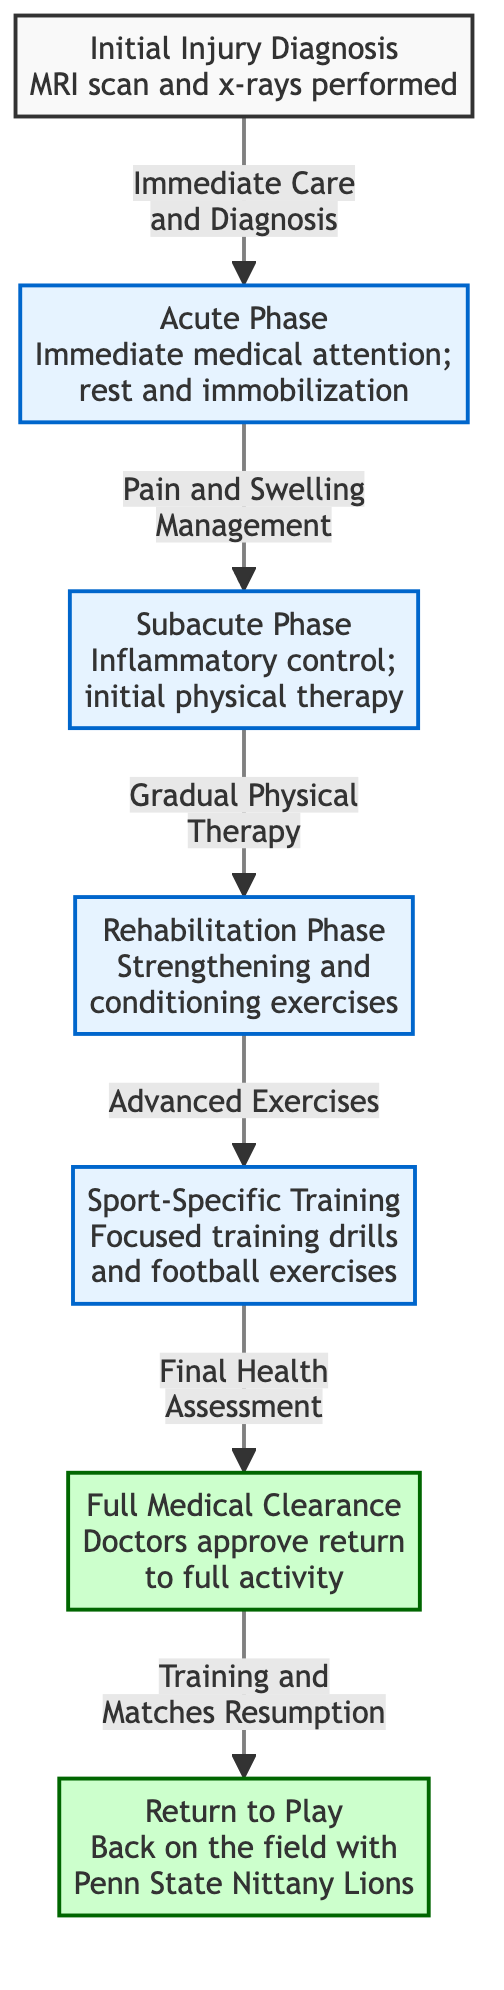What is the first phase after initial injury diagnosis? The diagram indicates that after the initial injury diagnosis, the first phase is the Acute Phase. This is shown as the first arrow leading from initial injury diagnosis to the acute phase node.
Answer: Acute Phase How many phases are included in the injury recovery timeline? By counting the nodes in the diagram that represent phases (excluding diagnosis and clearance nodes), there are five phases from initial injury to return to play.
Answer: Five phases What does the subacute phase focus on? The diagram shows that the subacute phase focuses on inflammatory control and initial physical therapy. This information is stated directly in the subacute phase node.
Answer: Inflammatory control; initial physical therapy In which phase is pain and swelling managed? The flow of the diagram shows that pain and swelling management occurs during the Acute Phase, as indicated by the label of the connecting arrow to the subacute phase.
Answer: Acute Phase What is the final step before returning to play? According to the diagram, the final step before returning to play is full medical clearance, as the arrow pointing from sport-specific training leads to this node before returning to play.
Answer: Full Medical Clearance What type of exercises occur during the rehabilitation phase? The rehabilitation phase is described in the diagram as focusing on strengthening and conditioning exercises, as noted in the node for that phase.
Answer: Strengthening and conditioning exercises What does the return to play indicate? The return to play node indicates that the athlete is back on the field with the Penn State Nittany Lions. This information can be found directly in the return to play node description.
Answer: Back on the field with Penn State Nittany Lions Which phase comes immediately before sport-specific training? The diagram shows that rehabilitation phase is immediately followed by sport-specific training, as indicated by the arrow connecting these two nodes directly.
Answer: Rehabilitation Phase What assessment occurs after sport-specific training? The diagram specifies that after sport-specific training, a final health assessment occurs, as stated in the arrow leading to the full medical clearance.
Answer: Final Health Assessment 